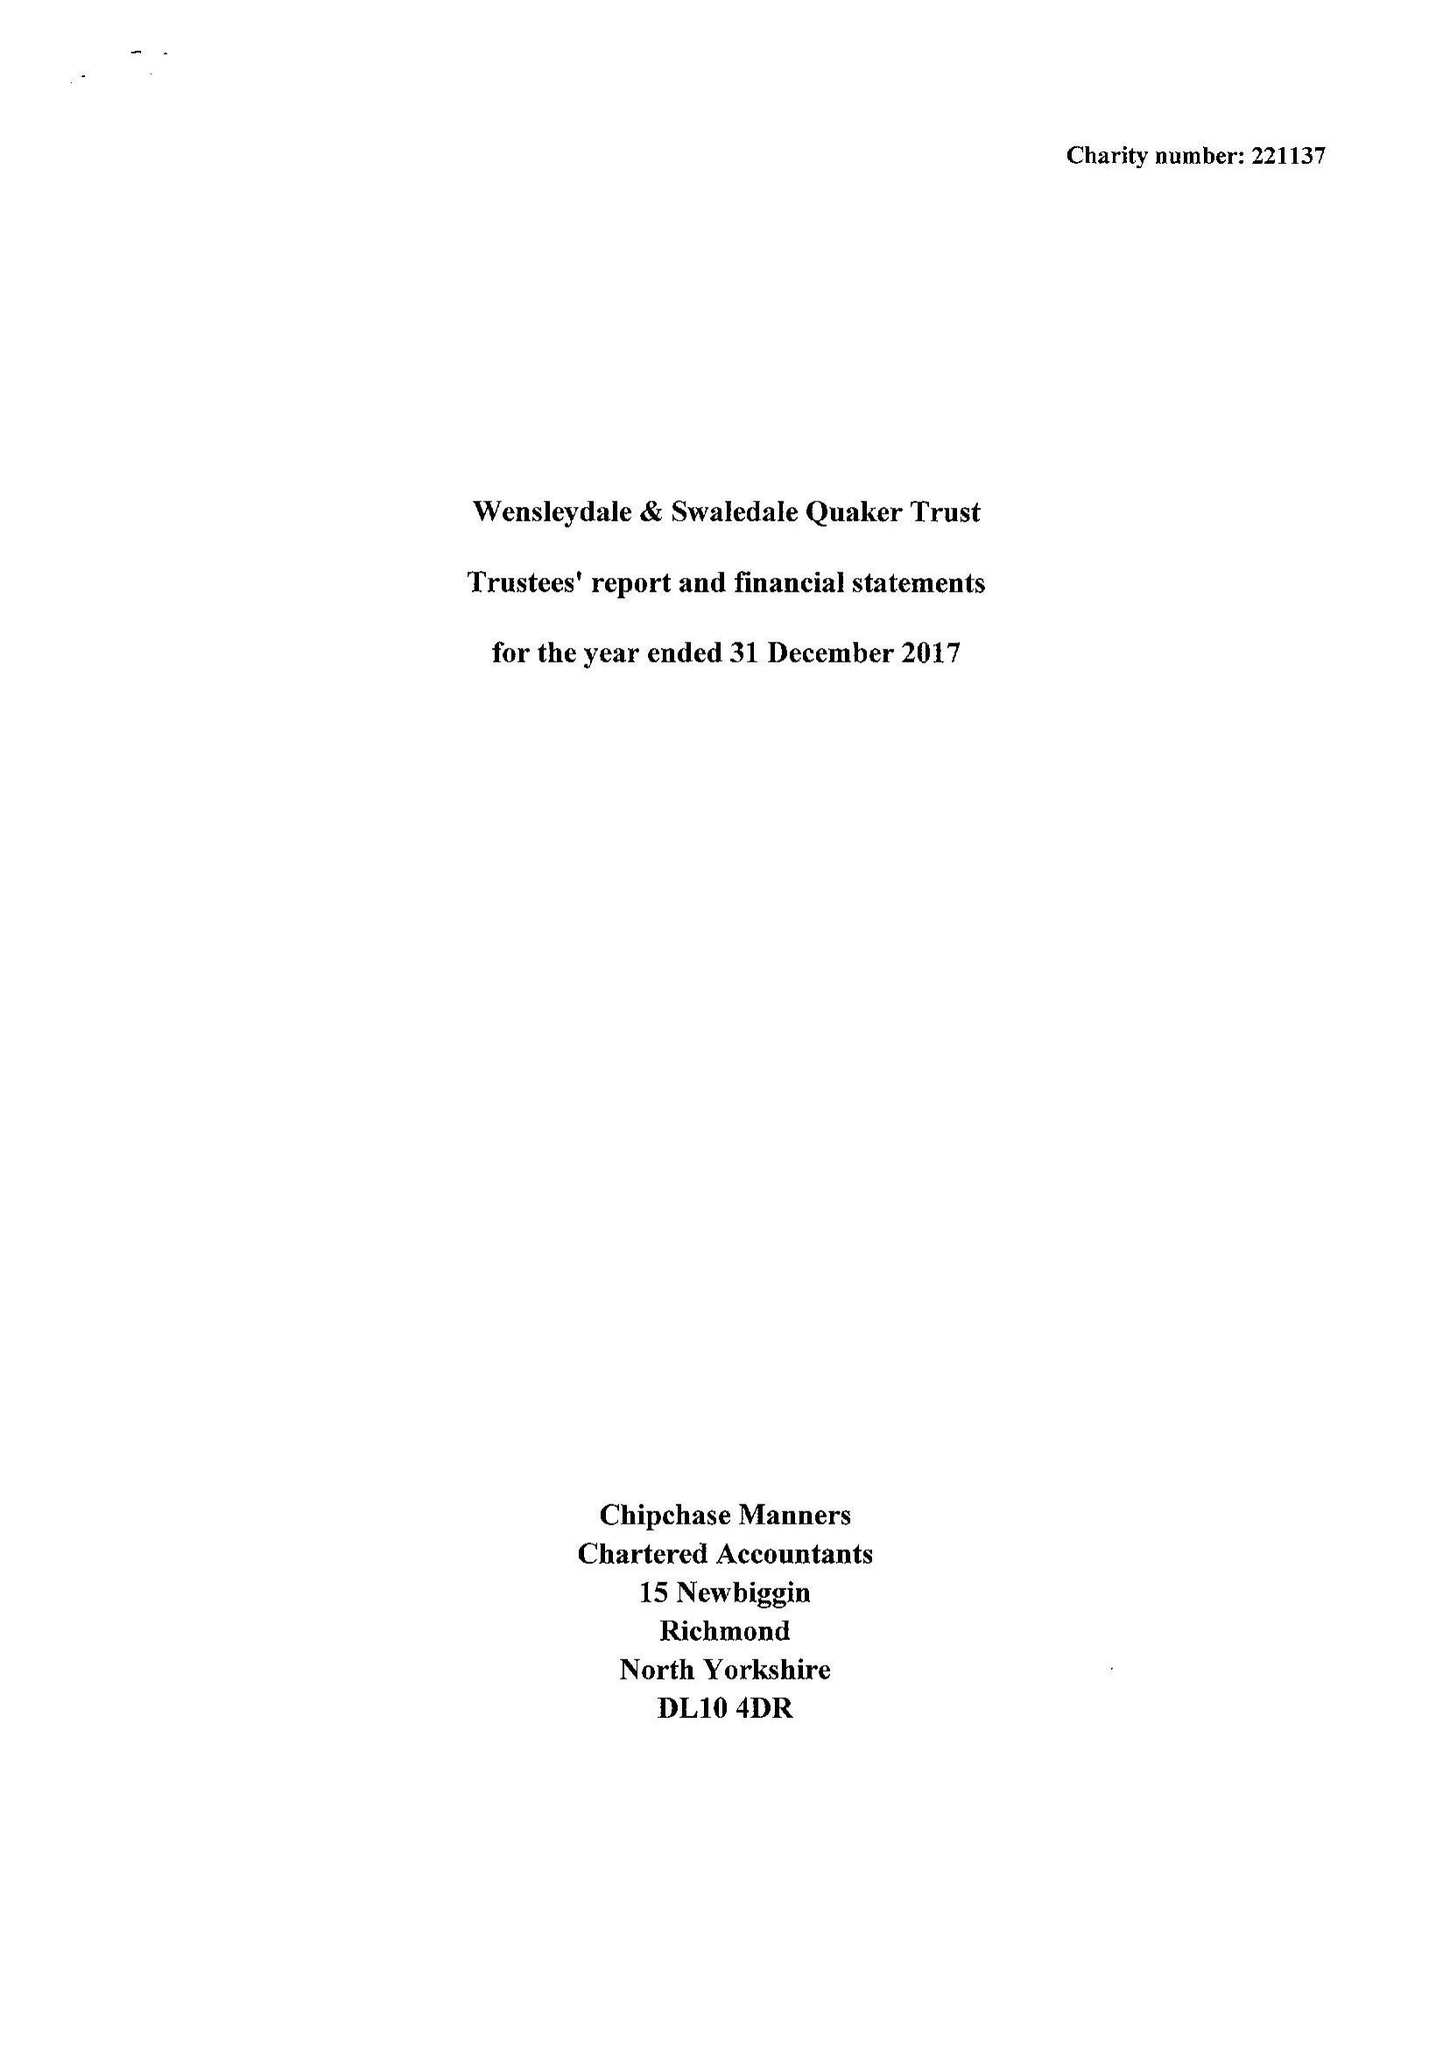What is the value for the charity_name?
Answer the question using a single word or phrase. Wensleydale and Swaledale Quaker Trust 